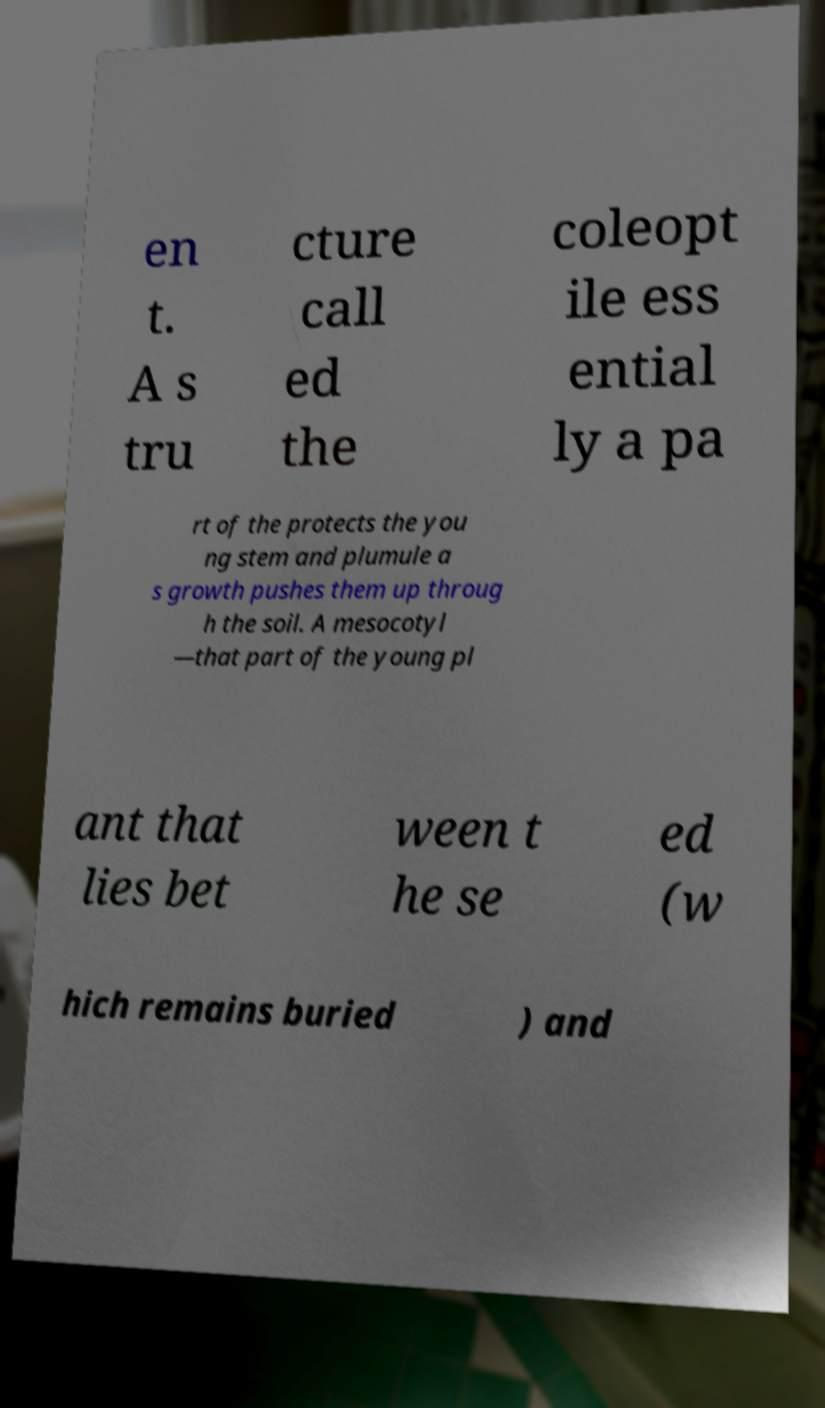Could you extract and type out the text from this image? en t. A s tru cture call ed the coleopt ile ess ential ly a pa rt of the protects the you ng stem and plumule a s growth pushes them up throug h the soil. A mesocotyl —that part of the young pl ant that lies bet ween t he se ed (w hich remains buried ) and 